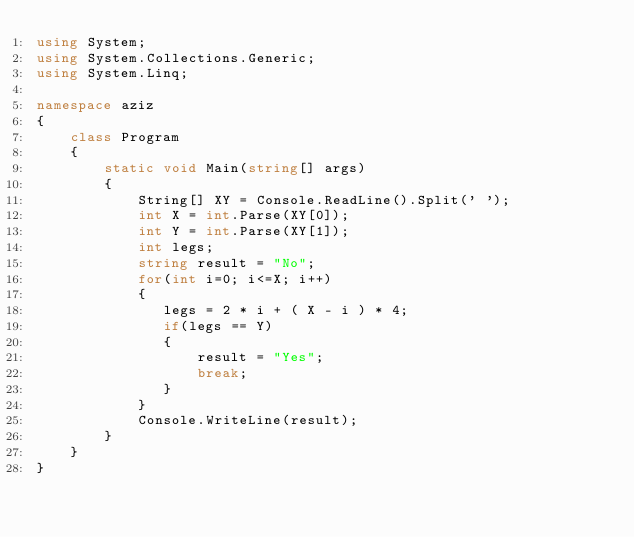<code> <loc_0><loc_0><loc_500><loc_500><_C#_>using System;
using System.Collections.Generic;
using System.Linq;

namespace aziz
{
    class Program
    {
        static void Main(string[] args)
        {
            String[] XY = Console.ReadLine().Split(' ');
            int X = int.Parse(XY[0]);
            int Y = int.Parse(XY[1]);
            int legs;
            string result = "No";
            for(int i=0; i<=X; i++)
            {
               legs = 2 * i + ( X - i ) * 4;
               if(legs == Y)
               {
                   result = "Yes";
                   break;
               }
            }
            Console.WriteLine(result);
        }
    }
}</code> 